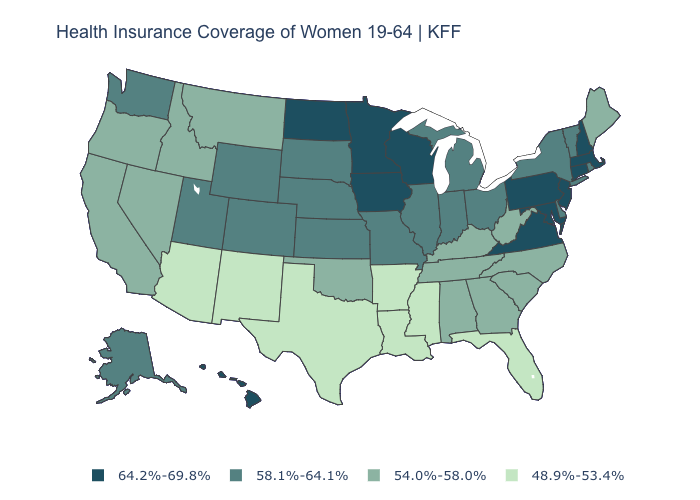Name the states that have a value in the range 64.2%-69.8%?
Answer briefly. Connecticut, Hawaii, Iowa, Maryland, Massachusetts, Minnesota, New Hampshire, New Jersey, North Dakota, Pennsylvania, Virginia, Wisconsin. What is the value of Delaware?
Give a very brief answer. 58.1%-64.1%. Does Massachusetts have the highest value in the USA?
Quick response, please. Yes. How many symbols are there in the legend?
Keep it brief. 4. Name the states that have a value in the range 54.0%-58.0%?
Answer briefly. Alabama, California, Georgia, Idaho, Kentucky, Maine, Montana, Nevada, North Carolina, Oklahoma, Oregon, South Carolina, Tennessee, West Virginia. Name the states that have a value in the range 48.9%-53.4%?
Give a very brief answer. Arizona, Arkansas, Florida, Louisiana, Mississippi, New Mexico, Texas. Name the states that have a value in the range 64.2%-69.8%?
Quick response, please. Connecticut, Hawaii, Iowa, Maryland, Massachusetts, Minnesota, New Hampshire, New Jersey, North Dakota, Pennsylvania, Virginia, Wisconsin. What is the value of North Carolina?
Concise answer only. 54.0%-58.0%. Does the first symbol in the legend represent the smallest category?
Answer briefly. No. Does Mississippi have the lowest value in the USA?
Write a very short answer. Yes. Which states hav the highest value in the MidWest?
Concise answer only. Iowa, Minnesota, North Dakota, Wisconsin. Among the states that border Oregon , does Nevada have the lowest value?
Give a very brief answer. Yes. What is the value of Hawaii?
Short answer required. 64.2%-69.8%. What is the value of Indiana?
Quick response, please. 58.1%-64.1%. 